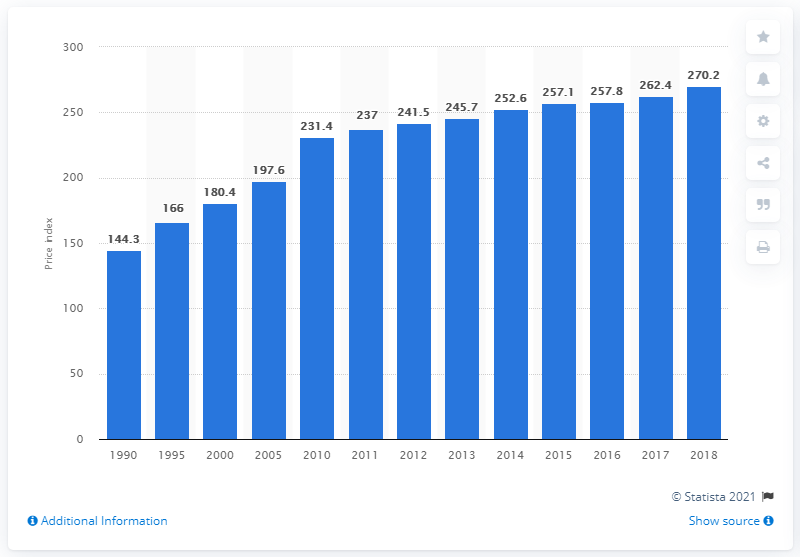Identify some key points in this picture. In 2018, the producer price index for plumbing fixtures and fittings was 270.2. 